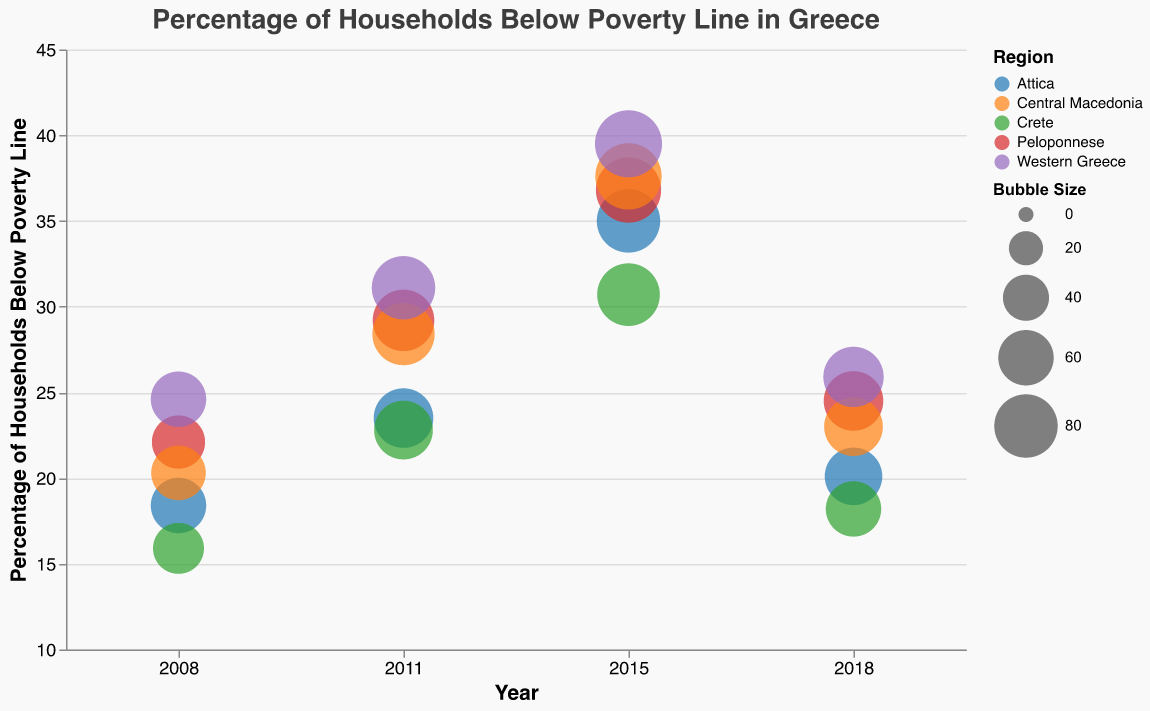What is the title of the chart? The title is at the top center of the chart and is meant to describe the overall topic of the data. The title is "Percentage of Households Below Poverty Line in Greece".
Answer: Percentage of Households Below Poverty Line in Greece In which year did the Peloponnese region have the highest percentage of households below the poverty line? Look for the largest bubble in the vertical axis for the Peloponnese region. The largest value is at 2015 with 36.8%.
Answer: 2015 Compare the percentage of households below the poverty line in Attica in 2008 and 2015. Which year had a higher percentage? Identify the bubbles for Attica in 2008 and 2015 and compare their positions on the vertical axis. In 2008, it was 18.4% and in 2015, it was 35.0%.
Answer: 2015 What is the percentage change in households below the poverty line in Western Greece from 2008 to 2018? Calculate the difference between the percentages in 2018 and 2008 for Western Greece and then use the formula: (2018 value - 2008 value) / 2008 value * 100. The change is (25.9 - 24.6) / 24.6 * 100 = 5.28%.
Answer: 5.28% Which region had the lowest percentage of households below the poverty line in 2018? Identify the bubbles for each region in 2018 and compare their positions on the vertical axis. Crete has the lowest percentage at 18.2%.
Answer: Crete Examine the bubble sizes for Central Macedonia. Which year had the largest bubble indicating the highest relative impact? Look at the bubble sizes for Central Macedonia across the years and identify the largest one. The largest bubble size is in 2015 with a size of 88.
Answer: 2015 How did the percentage of households below the poverty line change in Crete from 2008 to 2011? Look at the positions of Crete's bubbles in 2008 and 2011 on the vertical axis. In 2008, it was 15.9%, and in 2011, it was 22.8%, indicating an increase.
Answer: Increased Which region showed the greatest improvement (decrease) in percentage of households below the poverty line from 2015 to 2018? Compare the decrease in percentages for all regions between 2015 and 2018. Crete shows the greatest decrease from 30.7% to 18.2%, a difference of 12.5%.
Answer: Crete Analyze the data for Western Greece. Between which two consecutive years did Western Greece experience the largest increase in the percentage of households below the poverty line? Compare the increments in percentages across the years. The largest increase is between 2008 and 2011, from 24.6% to 31.1%, an increase of 6.5%.
Answer: 2008 to 2011 